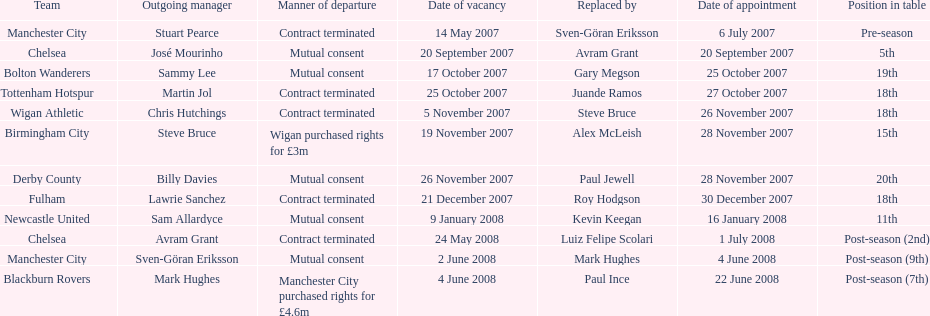What number of teams had a departure as a result of their contract termination? 5. 